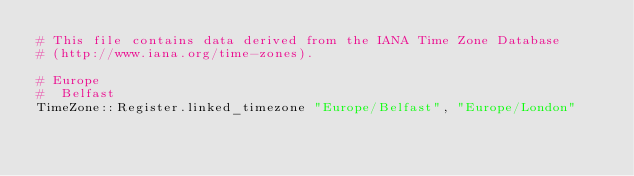<code> <loc_0><loc_0><loc_500><loc_500><_Crystal_># This file contains data derived from the IANA Time Zone Database
# (http://www.iana.org/time-zones).

# Europe
#  Belfast
TimeZone::Register.linked_timezone "Europe/Belfast", "Europe/London"
</code> 